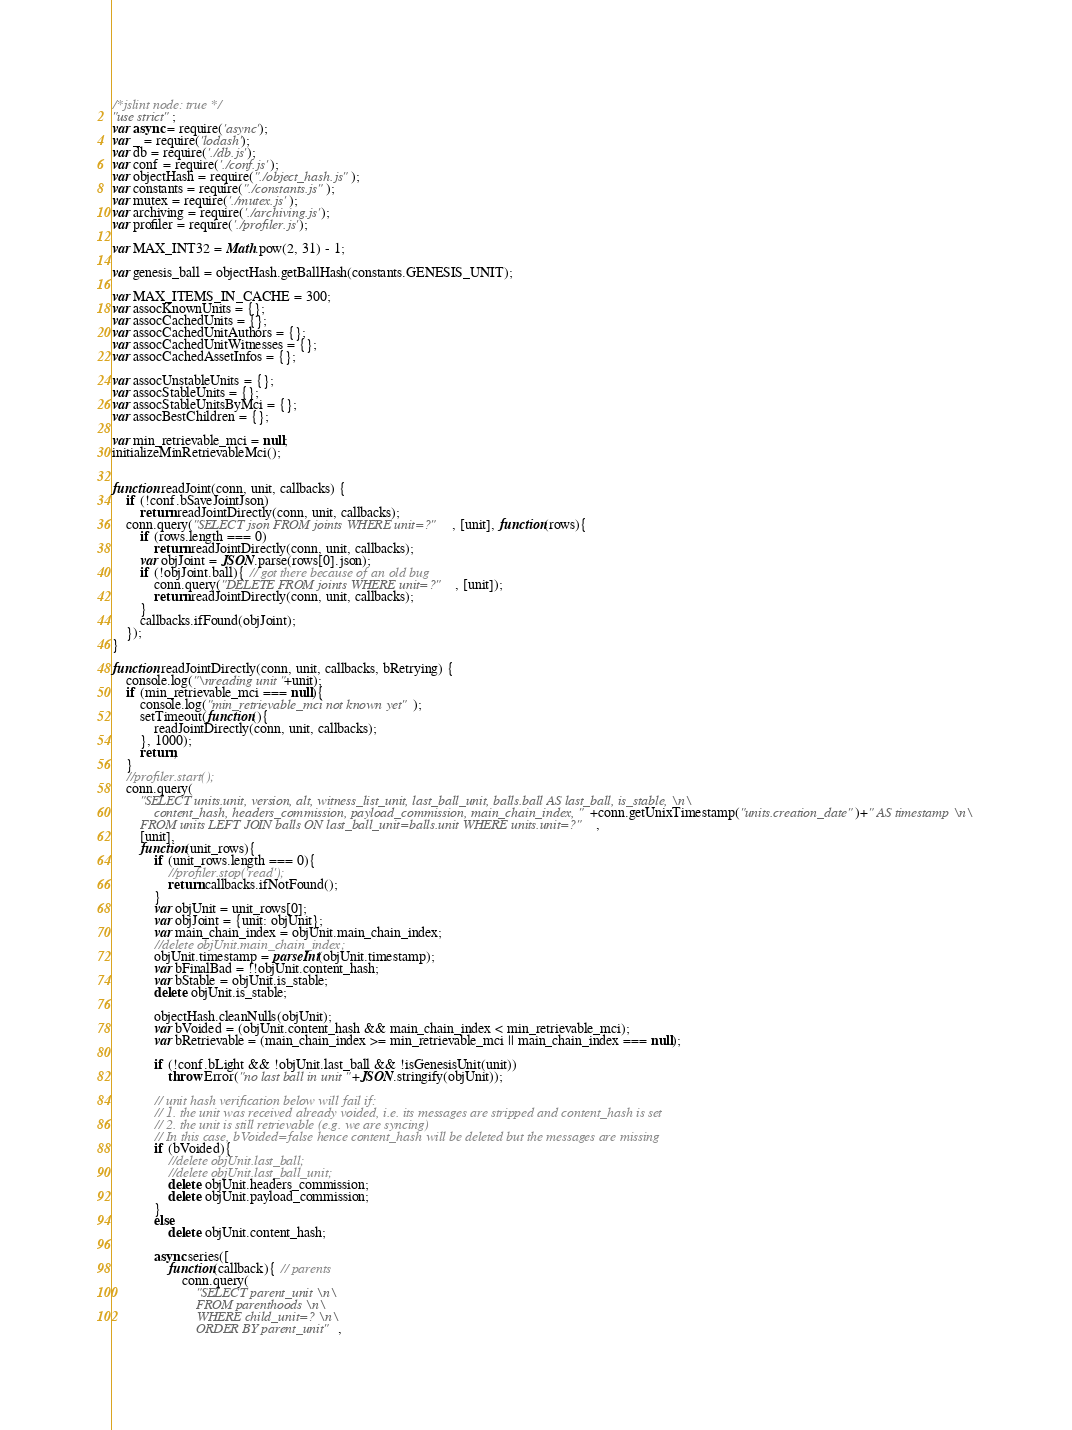<code> <loc_0><loc_0><loc_500><loc_500><_JavaScript_>/*jslint node: true */
"use strict";
var async = require('async');
var _ = require('lodash');
var db = require('./db.js');
var conf = require('./conf.js');
var objectHash = require("./object_hash.js");
var constants = require("./constants.js");
var mutex = require('./mutex.js');
var archiving = require('./archiving.js');
var profiler = require('./profiler.js');

var MAX_INT32 = Math.pow(2, 31) - 1;

var genesis_ball = objectHash.getBallHash(constants.GENESIS_UNIT);

var MAX_ITEMS_IN_CACHE = 300;
var assocKnownUnits = {};
var assocCachedUnits = {};
var assocCachedUnitAuthors = {};
var assocCachedUnitWitnesses = {};
var assocCachedAssetInfos = {};

var assocUnstableUnits = {};
var assocStableUnits = {};
var assocStableUnitsByMci = {};
var assocBestChildren = {};

var min_retrievable_mci = null;
initializeMinRetrievableMci();


function readJoint(conn, unit, callbacks) {
	if (!conf.bSaveJointJson)
		return readJointDirectly(conn, unit, callbacks);
	conn.query("SELECT json FROM joints WHERE unit=?", [unit], function(rows){
		if (rows.length === 0)
			return readJointDirectly(conn, unit, callbacks);
		var objJoint = JSON.parse(rows[0].json);
		if (!objJoint.ball){ // got there because of an old bug
			conn.query("DELETE FROM joints WHERE unit=?", [unit]);
			return readJointDirectly(conn, unit, callbacks);
		}
		callbacks.ifFound(objJoint);
	});
}

function readJointDirectly(conn, unit, callbacks, bRetrying) {
	console.log("\nreading unit "+unit);
	if (min_retrievable_mci === null){
		console.log("min_retrievable_mci not known yet");
		setTimeout(function(){
			readJointDirectly(conn, unit, callbacks);
		}, 1000);
		return;
	}
	//profiler.start();
	conn.query(
		"SELECT units.unit, version, alt, witness_list_unit, last_ball_unit, balls.ball AS last_ball, is_stable, \n\
			content_hash, headers_commission, payload_commission, main_chain_index, "+conn.getUnixTimestamp("units.creation_date")+" AS timestamp \n\
		FROM units LEFT JOIN balls ON last_ball_unit=balls.unit WHERE units.unit=?", 
		[unit], 
		function(unit_rows){
			if (unit_rows.length === 0){
				//profiler.stop('read');
				return callbacks.ifNotFound();
			}
			var objUnit = unit_rows[0];
			var objJoint = {unit: objUnit};
			var main_chain_index = objUnit.main_chain_index;
			//delete objUnit.main_chain_index;
			objUnit.timestamp = parseInt(objUnit.timestamp);
			var bFinalBad = !!objUnit.content_hash;
			var bStable = objUnit.is_stable;
			delete objUnit.is_stable;

			objectHash.cleanNulls(objUnit);
			var bVoided = (objUnit.content_hash && main_chain_index < min_retrievable_mci);
			var bRetrievable = (main_chain_index >= min_retrievable_mci || main_chain_index === null);
			
			if (!conf.bLight && !objUnit.last_ball && !isGenesisUnit(unit))
				throw Error("no last ball in unit "+JSON.stringify(objUnit));
			
			// unit hash verification below will fail if:
			// 1. the unit was received already voided, i.e. its messages are stripped and content_hash is set
			// 2. the unit is still retrievable (e.g. we are syncing)
			// In this case, bVoided=false hence content_hash will be deleted but the messages are missing
			if (bVoided){
				//delete objUnit.last_ball;
				//delete objUnit.last_ball_unit;
				delete objUnit.headers_commission;
				delete objUnit.payload_commission;
			}
			else
				delete objUnit.content_hash;

			async.series([
				function(callback){ // parents
					conn.query(
						"SELECT parent_unit \n\
						FROM parenthoods \n\
						WHERE child_unit=? \n\
						ORDER BY parent_unit", </code> 